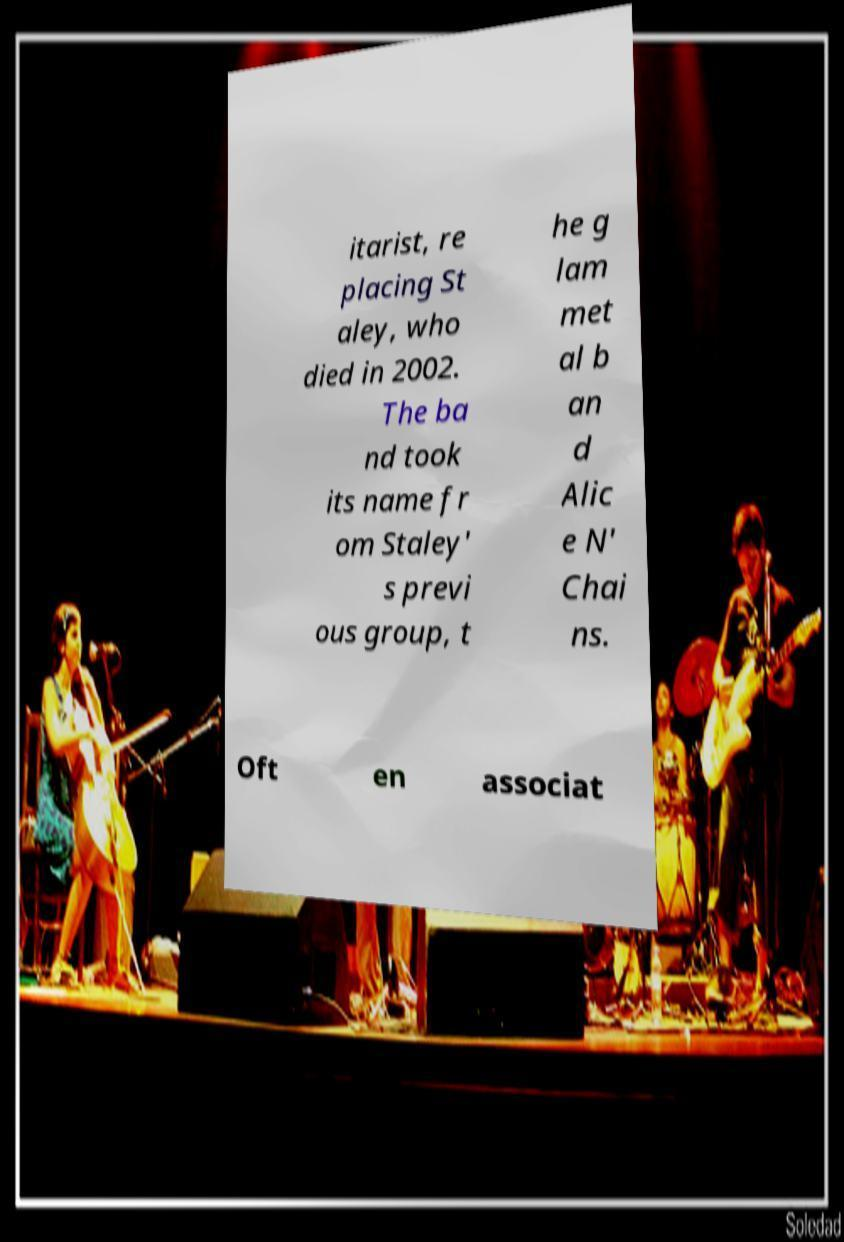What messages or text are displayed in this image? I need them in a readable, typed format. itarist, re placing St aley, who died in 2002. The ba nd took its name fr om Staley' s previ ous group, t he g lam met al b an d Alic e N' Chai ns. Oft en associat 